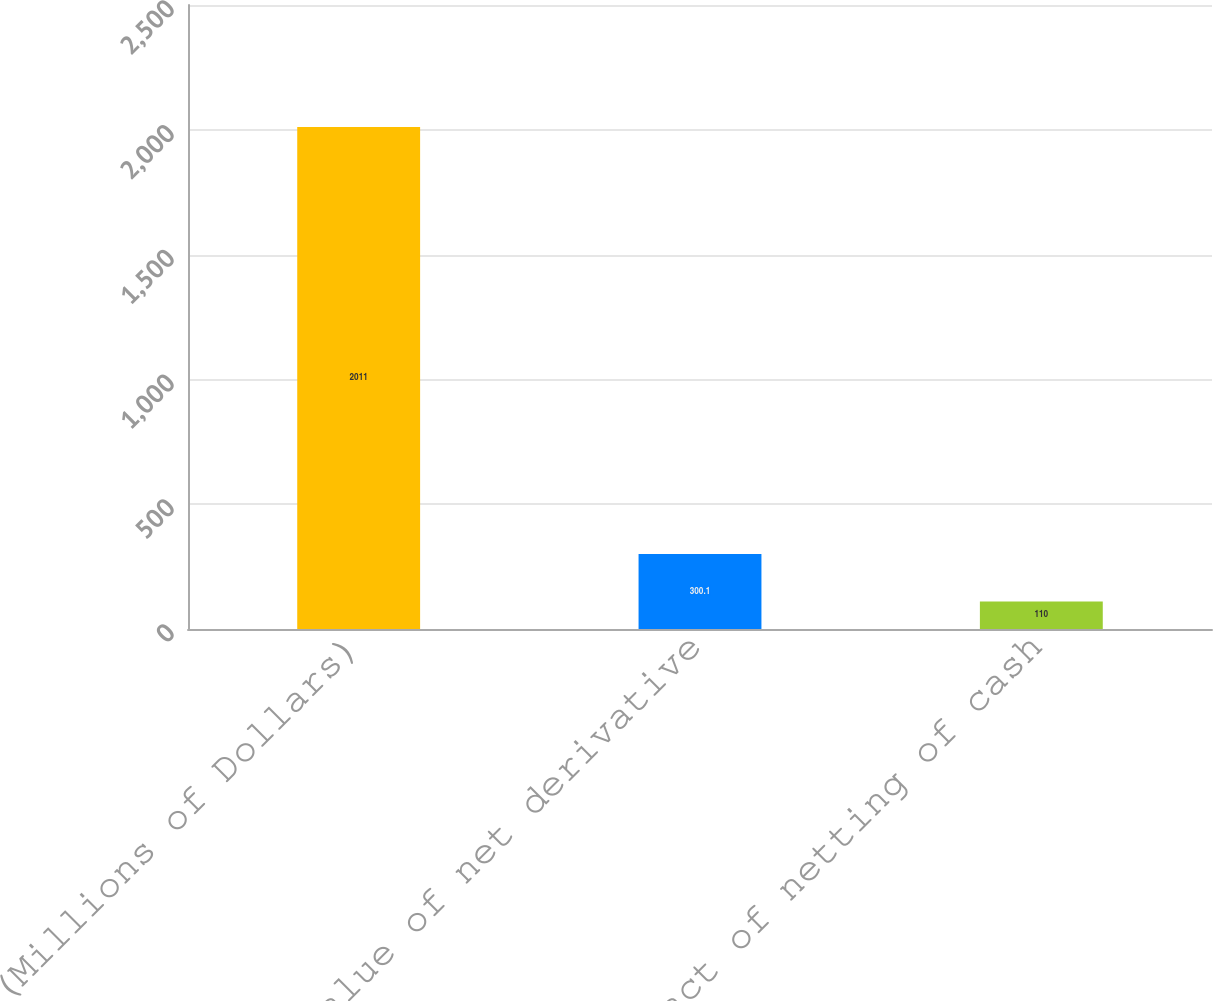Convert chart to OTSL. <chart><loc_0><loc_0><loc_500><loc_500><bar_chart><fcel>(Millions of Dollars)<fcel>Fair value of net derivative<fcel>Impact of netting of cash<nl><fcel>2011<fcel>300.1<fcel>110<nl></chart> 